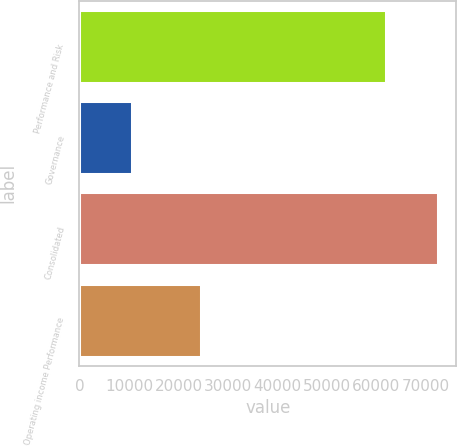<chart> <loc_0><loc_0><loc_500><loc_500><bar_chart><fcel>Performance and Risk<fcel>Governance<fcel>Consolidated<fcel>Operating income Performance<nl><fcel>61841<fcel>10683<fcel>72524<fcel>24601<nl></chart> 